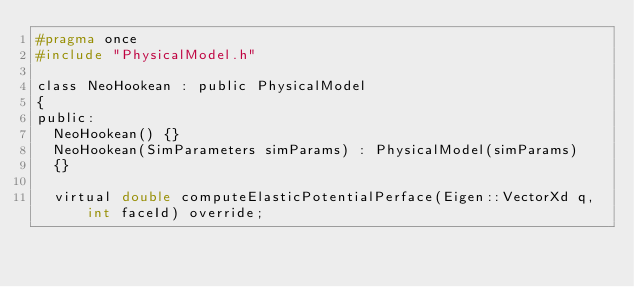Convert code to text. <code><loc_0><loc_0><loc_500><loc_500><_C_>#pragma once
#include "PhysicalModel.h"

class NeoHookean : public PhysicalModel
{
public:
	NeoHookean() {}
	NeoHookean(SimParameters simParams) : PhysicalModel(simParams)
	{}

	virtual double computeElasticPotentialPerface(Eigen::VectorXd q, int faceId) override;</code> 